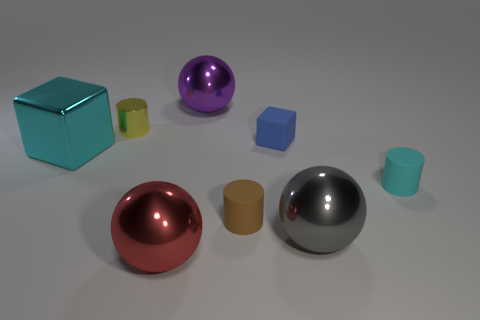Add 1 yellow cylinders. How many objects exist? 9 Subtract all spheres. How many objects are left? 5 Add 3 tiny rubber cylinders. How many tiny rubber cylinders are left? 5 Add 4 small blocks. How many small blocks exist? 5 Subtract 1 yellow cylinders. How many objects are left? 7 Subtract all brown balls. Subtract all brown cylinders. How many objects are left? 7 